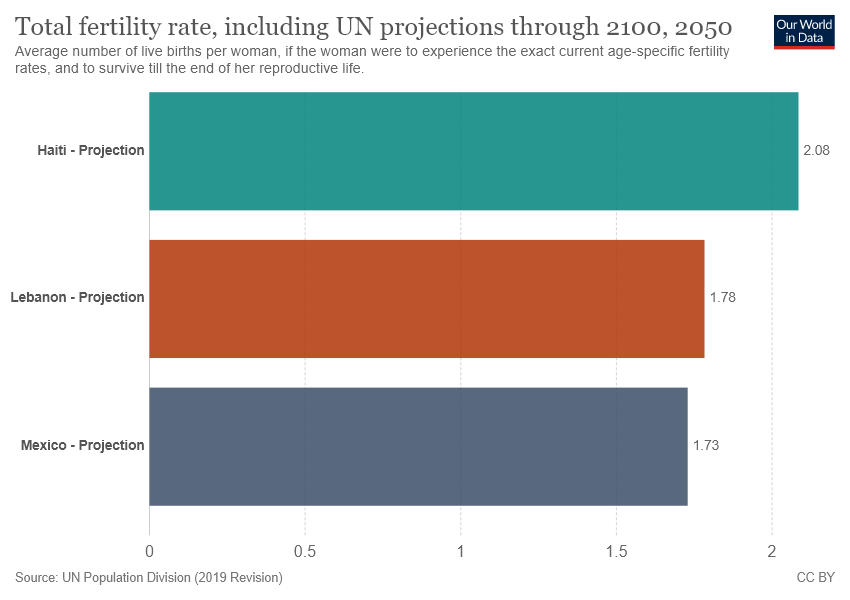Outline some significant characteristics in this image. The value of Mexico's projection is not greater than Lebanon's projection. The fertility rate of dark blue is the lowest among all the colors depicted in the graph. 